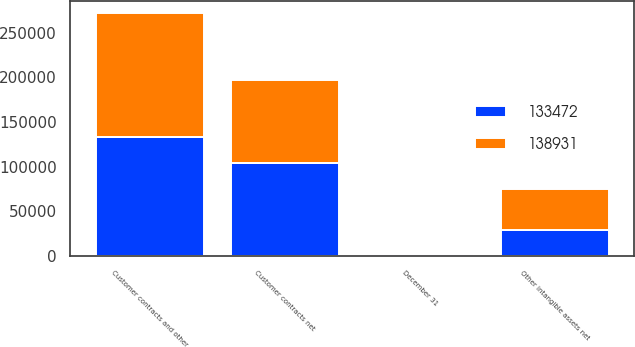Convert chart to OTSL. <chart><loc_0><loc_0><loc_500><loc_500><stacked_bar_chart><ecel><fcel>December 31<fcel>Customer contracts net<fcel>Other intangible assets net<fcel>Customer contracts and other<nl><fcel>138931<fcel>2015<fcel>92815<fcel>46116<fcel>138931<nl><fcel>133472<fcel>2014<fcel>104657<fcel>28815<fcel>133472<nl></chart> 